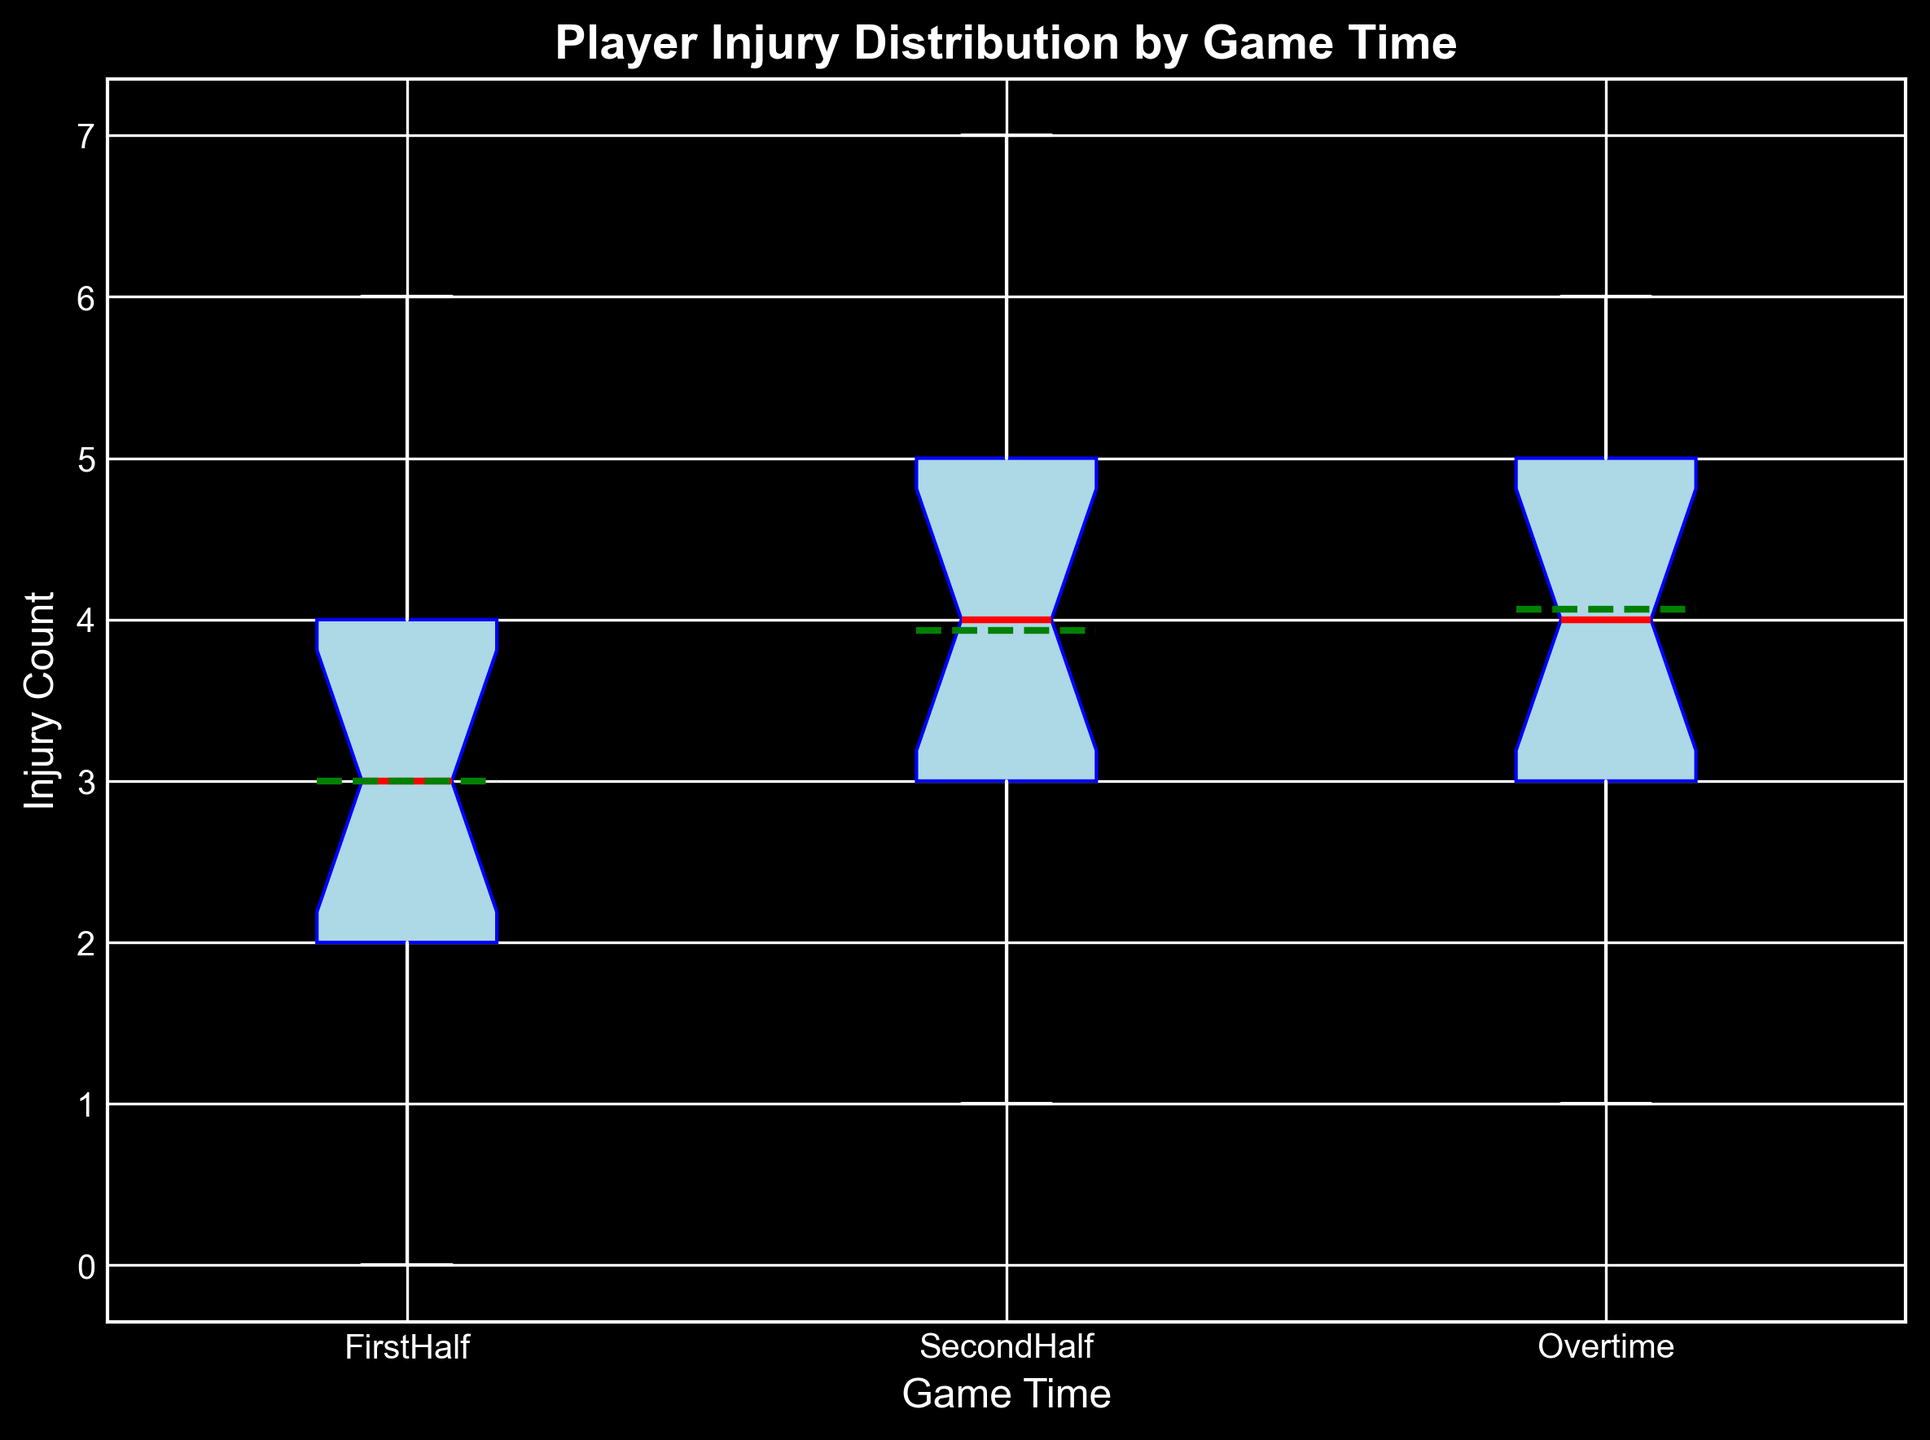What is the median injury count during the First Half? The median is the middle value when the data points are ordered. For the First Half, the ordered injury counts are 0, 1, 2, 2, 2, 2, 3, 3, 3, 3, 4, 4, 5, 5, 6. The middle value is the 8th value, which is 3.
Answer: 3 Which game time period has the highest mean injury count? The mean is the average of the data points. Visually, the plot would show this with a green line closer to a higher count. By comparing means visually, Overtime has the highest mean injury count.
Answer: Overtime How does the interquartile range (IQR) of the Second Half compare to the First Half? The IQR is the range between the first quartile (Q1) and the third quartile (Q3). The box height in the Second Half box plot visually looks more extended than the First Half, indicating a larger IQR.
Answer: Second Half has a larger IQR What is the range of injury count in the Overtime period? The range is the difference between the maximum and minimum values. From the plot, Overtime's whiskers extend from 1 to 6. The range is 6 - 1 = 5.
Answer: 5 Is there an outlier in the First Half injury counts? In a box plot, outliers are usually shown as points outside the whiskers. The plot does not show any points outside the whiskers for the First Half.
Answer: No Which game time period has the highest median injury count? The median is marked by the red line in each box plot. By comparing the red line's level, the Second Half has the highest median injury count.
Answer: Second Half Is the mean injury count higher or lower than the median injury count in the First Half? The mean is shown by a green line, and the median by a red line. In the First Half box plot, the green line (mean) is very close to the red line (median), but slightly higher.
Answer: Higher How do the whiskers of the First Half compare to the Second Half? Whiskers represent the range of data within 1.5 times the IQR. Visually, the whiskers for the Second Half extend further than those for the First Half.
Answer: Second Half has longer whiskers How many data points are there in the Overtime injury counts? By counting the individual data points used to construct the Overtime box plot, which involves checking the initial data itself, we see there are 15 points.
Answer: 15 